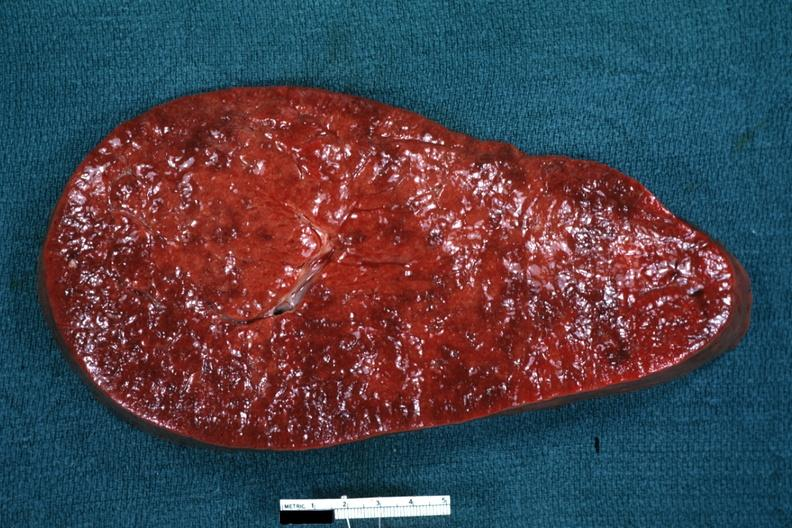s hematologic present?
Answer the question using a single word or phrase. Yes 